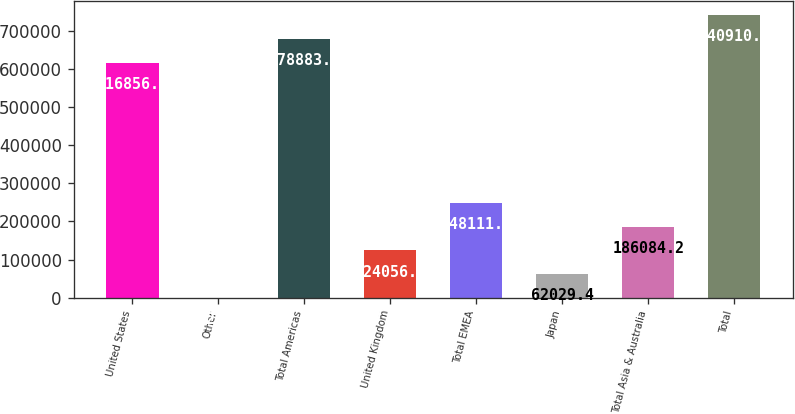Convert chart. <chart><loc_0><loc_0><loc_500><loc_500><bar_chart><fcel>United States<fcel>Other<fcel>Total Americas<fcel>United Kingdom<fcel>Total EMEA<fcel>Japan<fcel>Total Asia & Australia<fcel>Total<nl><fcel>616856<fcel>2<fcel>678883<fcel>124057<fcel>248112<fcel>62029.4<fcel>186084<fcel>740911<nl></chart> 